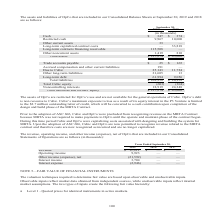According to Cubic's financial document, What does the table represent? assets and liabilities of OpCo that are included in our Consolidated Balance Sheets at September 30, 2019 and 2018. The document states: "The assets and liabilities of OpCo that are included in our Consolidated Balance Sheets at September 30, 2019 and 2018 are as follows:..." Also, What will Cubic's outstanding letter of credit be converted to? a cash contribution upon completion of the design and build phase of the MBTA Contract. The document states: "ding letter of credit, which will be converted to a cash contribution upon completion of the design and build phase of the MBTA Contract. Prior to the..." Also, What are the items under Total assets? The document contains multiple relevant values: Cash, Restricted cash, Other current assets, Long-term capitalized contract costs, Long-term contracts financing receivable, Other noncurrent assets. From the document: "Long-term contracts financing receivable 115,508 — Other noncurrent assets 1,419 810 ong-term contracts financing receivable 115,508 — Other noncurren..." Additionally, In which year is the amount of Cash larger? According to the financial document, 2018. The relevant text states: "olidated Balance Sheets at September 30, 2019 and 2018 are as follows:..." Also, can you calculate: What is the change in total assets from 2018 to 2019? Based on the calculation: 127,274-45,002, the result is 82272 (in thousands). This is based on the information: "Total assets $ 127,274 $ 45,002 Total assets $ 127,274 $ 45,002..." The key data points involved are: 127,274, 45,002. Also, can you calculate: What is the percentage change in cash? To answer this question, I need to perform calculations using the financial data. The calculation is: (347-374)/374, which equals -7.22 (percentage). This is based on the information: "Cash $ 347 $ 374 Restricted cash 9,967 10,000 Cash $ 347 $ 374 Restricted cash 9,967 10,000..." The key data points involved are: 347, 374. 